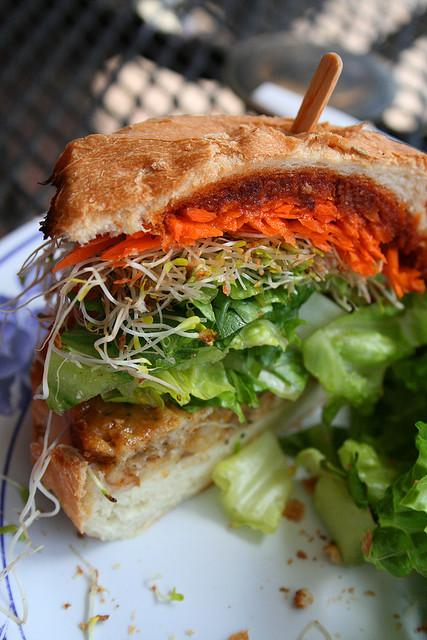This sandwich is probably being eaten in what kind of setting?

Choices:
A) outdoor
B) office
C) cafeteria
D) kitchen outdoor 